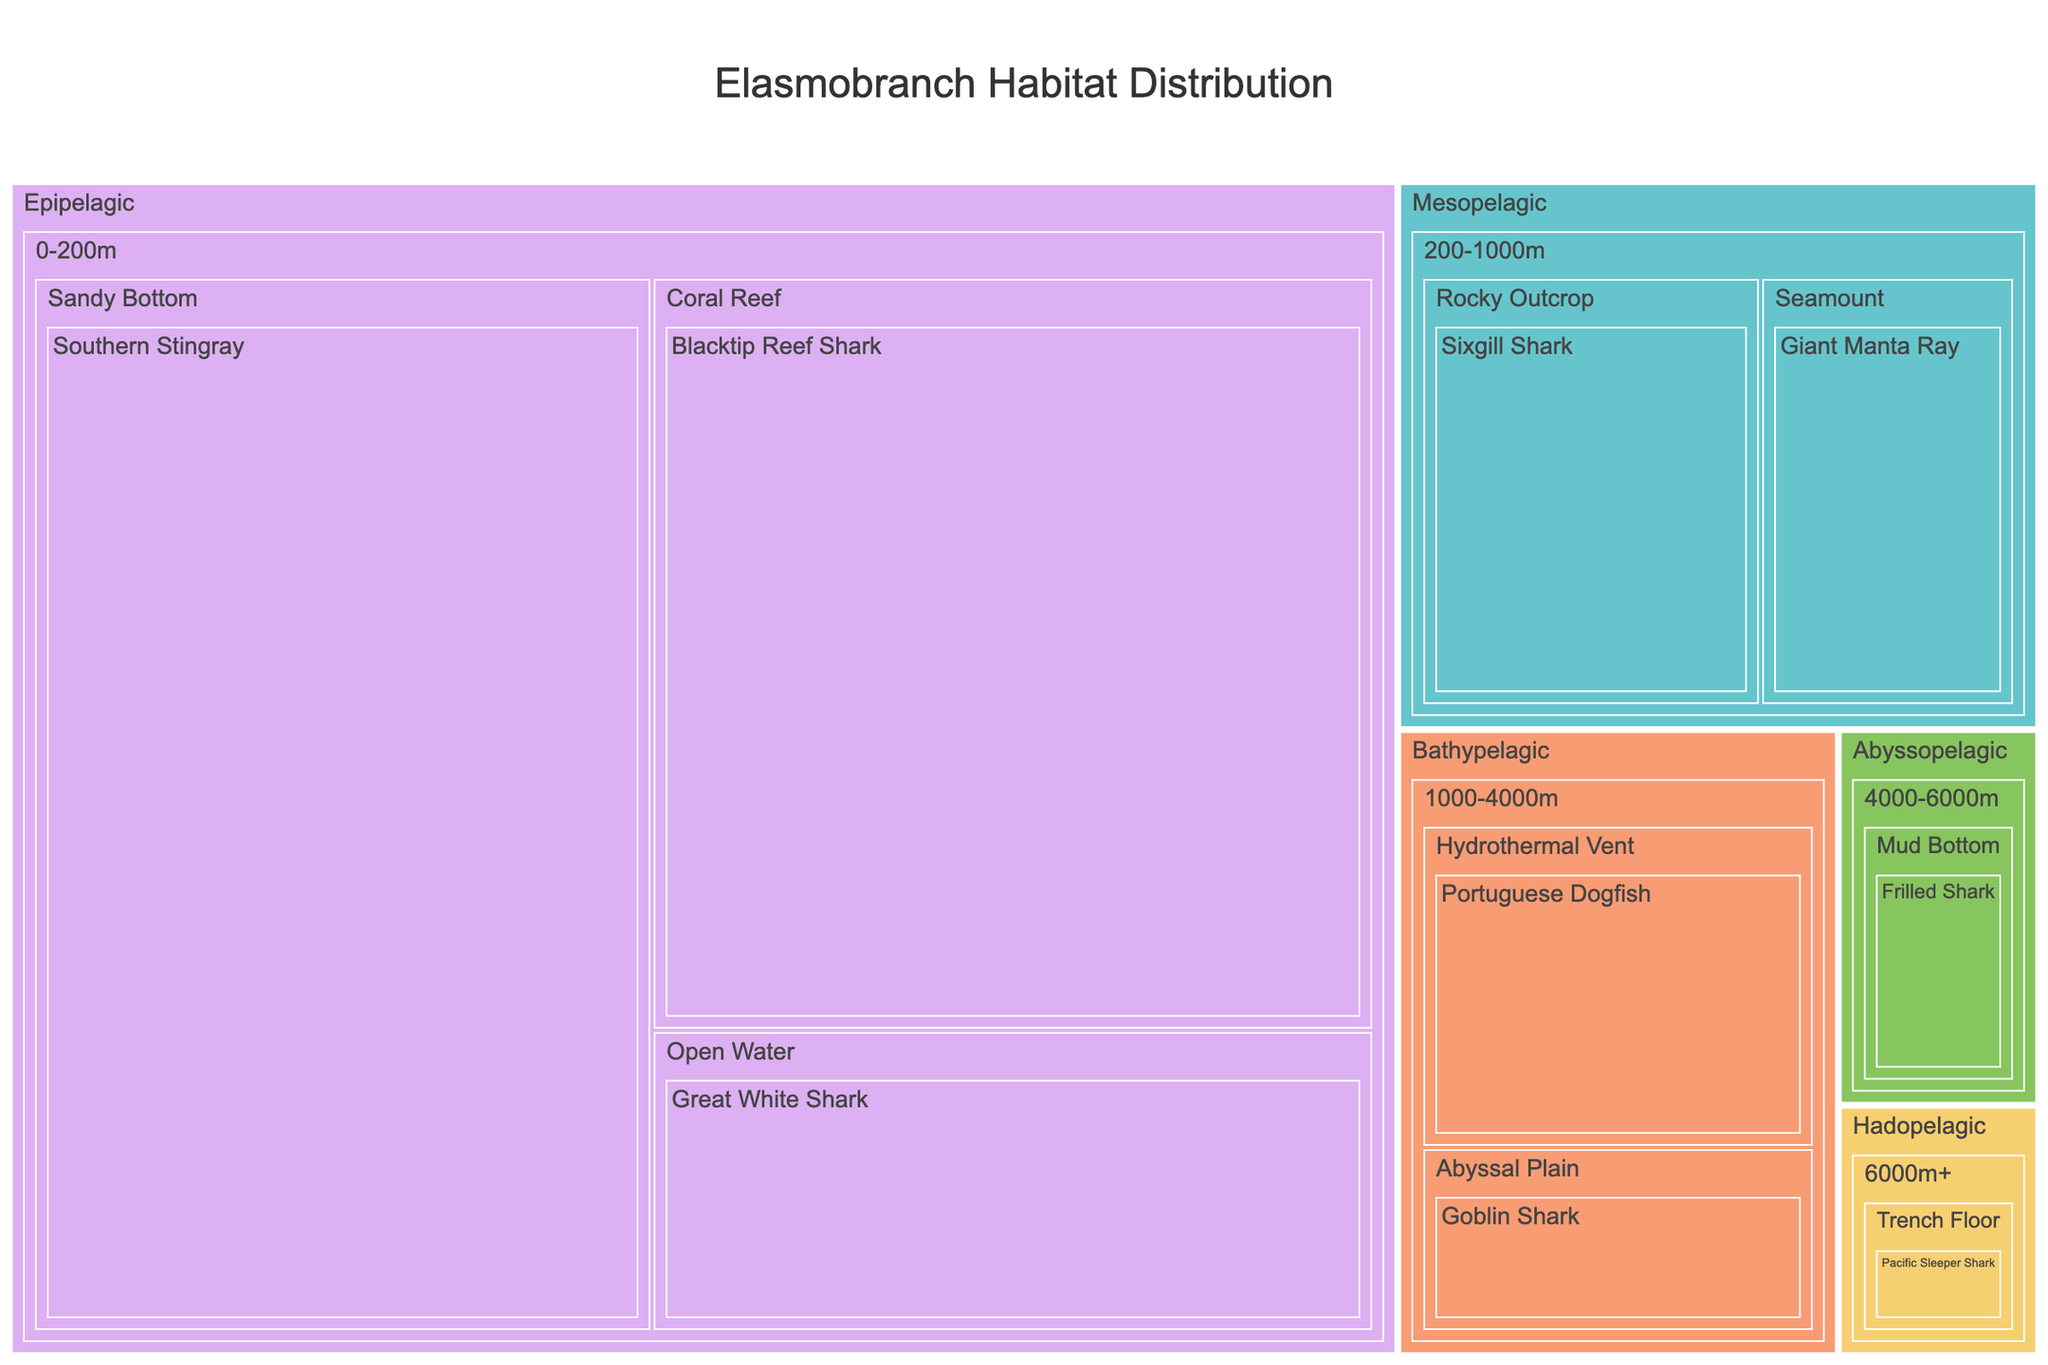What is the title of the Treemap? The title is always located at the top of a Treemap. By reading the title written there, we can determine what the figure depicts.
Answer: Elasmobranch Habitat Distribution Which species has the highest population in the Epipelagic zone? Look for the block corresponding to the Epipelagic zone, and identify the species with the largest block, which indicates the highest population.
Answer: Southern Stingray How many species are present in the Bathypelagic zone? Identify the Bathypelagic zone and count the different species listed within that section.
Answer: 2 What is the population difference between the Blacktip Reef Shark and the Portuguese Dogfish? Locate the population numbers for both species and subtract the smaller from the larger to find the difference.
Answer: 1800 Which Elasmobranch species inhabits the trench floor in the Hadopelagic zone? Navigate through the Treemap to the Hadopelagic section and identify the species listed at the Trench Floor substrate.
Answer: Pacific Sleeper Shark Which species inhabits open water at depths from 0-200m? Look for the Epipelagic zone with the 'Open Water' substrate and find the species name located there.
Answer: Great White Shark What is the total population of elasmobranchs in the Mesopelagic zone? Locate the Mesopelagic section and sum the populations of all species listed in that zone.
Answer: 1400 Compare the populations of elasmobranchs living in coral reefs and rocky outcrops. Which substrate supports a larger population? Identify populations in the 'Coral Reef' substrate and 'Rocky Outcrop' substrate, then compare the total populations listed in each.
Answer: Coral Reef Which ocean zone has the fewest species? Count the number of species in each ocean zone, then identify the zone with the lowest count.
Answer: Hadopelagic What is the combined population of the Sixgill Shark and the Giant Manta Ray? Add the populations of Sixgill Shark and Giant Manta Ray by identifying their respective boxes and summing their populations.
Answer: 1400 